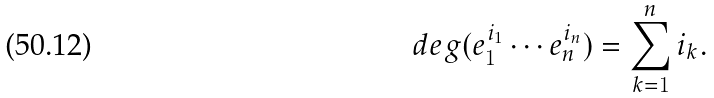Convert formula to latex. <formula><loc_0><loc_0><loc_500><loc_500>d e g ( e _ { 1 } ^ { i _ { 1 } } \cdots e _ { n } ^ { i _ { n } } ) = \sum _ { k = 1 } ^ { n } i _ { k } .</formula> 